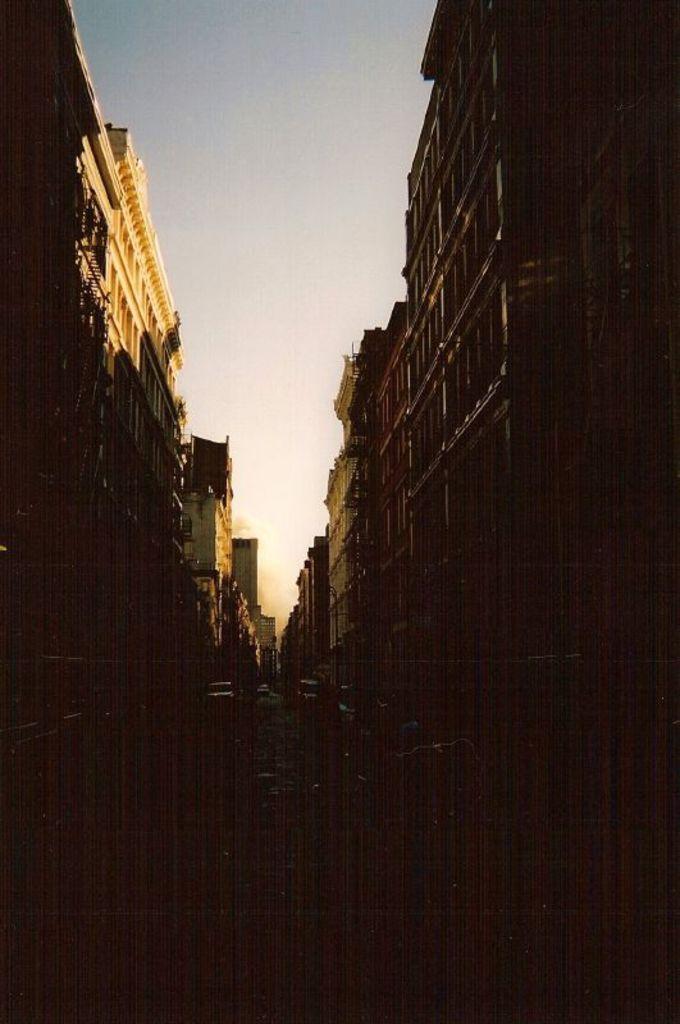Can you describe this image briefly? to both sides of the image there are buildings. In the center of the image there is road on which there are vehicles. At the top of the image there is sky. 